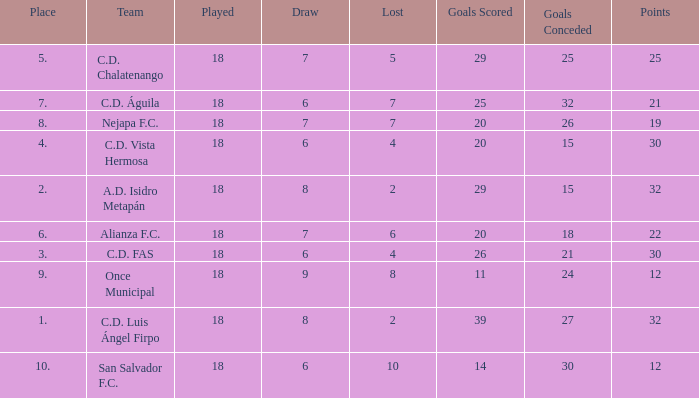What is the sum of draw with a lost smaller than 6, and a place of 5, and a goals scored less than 29? None. 